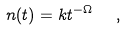Convert formula to latex. <formula><loc_0><loc_0><loc_500><loc_500>n ( t ) = k t ^ { - \Omega } \ \ ,</formula> 